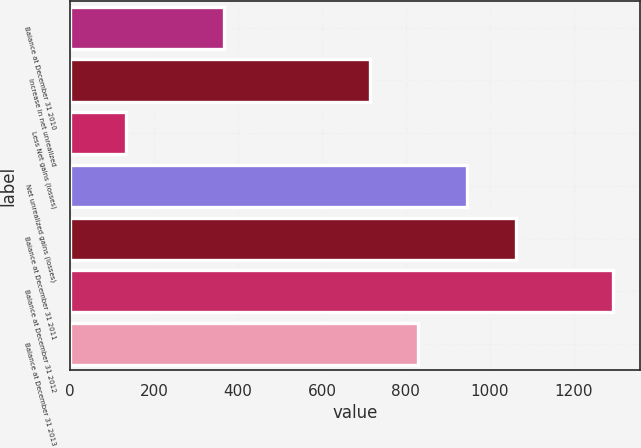Convert chart. <chart><loc_0><loc_0><loc_500><loc_500><bar_chart><fcel>Balance at December 31 2010<fcel>Increase in net unrealized<fcel>Less Net gains (losses)<fcel>Net unrealized gains (losses)<fcel>Balance at December 31 2011<fcel>Balance at December 31 2012<fcel>Balance at December 31 2013<nl><fcel>365.7<fcel>713.4<fcel>133.9<fcel>945.2<fcel>1061.1<fcel>1292.9<fcel>829.3<nl></chart> 